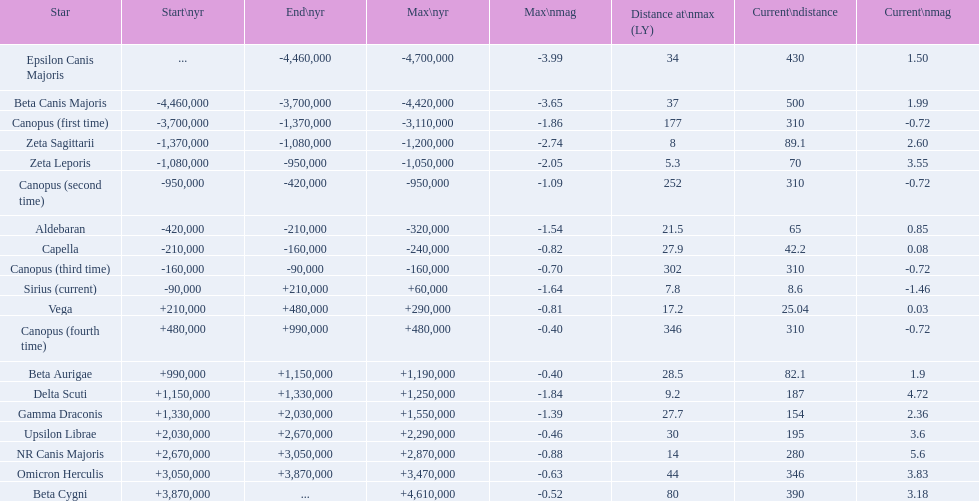What are all the stars? Epsilon Canis Majoris, Beta Canis Majoris, Canopus (first time), Zeta Sagittarii, Zeta Leporis, Canopus (second time), Aldebaran, Capella, Canopus (third time), Sirius (current), Vega, Canopus (fourth time), Beta Aurigae, Delta Scuti, Gamma Draconis, Upsilon Librae, NR Canis Majoris, Omicron Herculis, Beta Cygni. Of those, which star has a maximum distance of 80? Beta Cygni. 